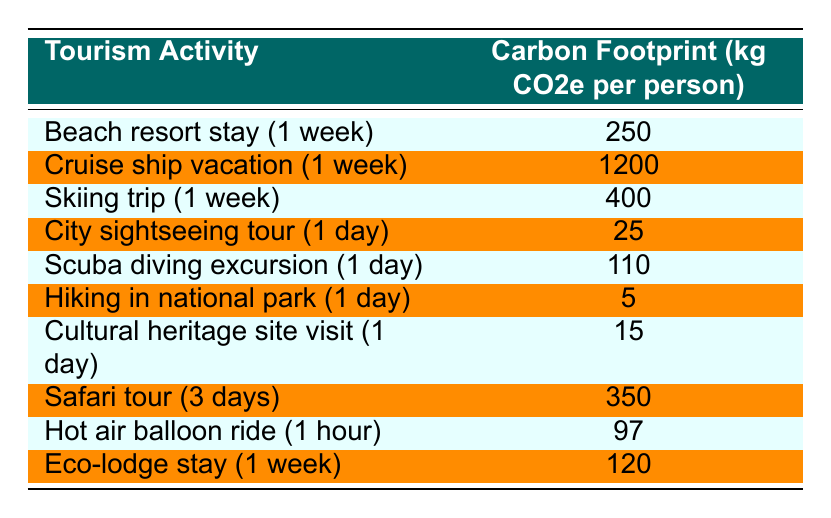What is the carbon footprint of a city sightseeing tour for one day? The table shows that the carbon footprint for a city sightseeing tour (1 day) is listed as 25 kg CO2e per person.
Answer: 25 kg CO2e Which tourism activity has the highest carbon footprint? According to the table, the cruise ship vacation (1 week) has the highest carbon footprint at 1200 kg CO2e per person.
Answer: Cruise ship vacation (1 week) How much more CO2e is produced by a cruise ship vacation compared to a hiking trip in a national park? The carbon footprint for a cruise ship vacation (1 week) is 1200 kg CO2e, while the footprint for hiking in a national park (1 day) is 5 kg CO2e. The difference is 1200 - 5 = 1195 kg CO2e.
Answer: 1195 kg CO2e What is the total carbon footprint of a person doing a skiing trip followed by a scuba diving excursion? From the table, the skiing trip (1 week) has a footprint of 400 kg CO2e and the scuba diving excursion (1 day) has 110 kg CO2e. Adding both gives 400 + 110 = 510 kg CO2e.
Answer: 510 kg CO2e Is the carbon footprint of an eco-lodge stay higher than that of a cultural heritage site visit? The eco-lodge stay (1 week) has a carbon footprint of 120 kg CO2e, while the cultural heritage site visit (1 day) is at 15 kg CO2e. Since 120 is greater than 15, the statement is true.
Answer: Yes How does the carbon footprint of a safari tour compare to that of a hot air balloon ride? The safari tour (3 days) has a carbon footprint of 350 kg CO2e, while the hot air balloon ride (1 hour) has a footprint of 97 kg CO2e. Since 350 is greater than 97, the safari tour has a higher footprint.
Answer: Safari tour has a higher footprint What is the average carbon footprint of a person for the tourism activities listed in the table for activities lasting one day? The activities lasting one day listed are city sightseeing (25 kg), scuba diving (110 kg), hiking (5 kg), and cultural heritage site (15 kg). Summing these gives 25 + 110 + 5 + 15 = 155 kg CO2e. Dividing by the number of activities (4), the average is 155/4 = 38.75 kg CO2e.
Answer: 38.75 kg CO2e Which tourism activities have a carbon footprint of less than 100 kg CO2e? The table shows the carbon footprints of cultural heritage site visit (15 kg), hiking in national park (5 kg), city sightseeing tour (25 kg), and hot air balloon ride (97 kg). These activities have footprints less than 100 kg CO2e.
Answer: Cultural heritage site visit, hiking in national park, city sightseeing tour, hot air balloon ride How much carbon dioxide equivalent would a person produce if they stayed at a beach resort for a week and then went scuba diving for a day? The beach resort stay for a week produces 250 kg CO2e and the scuba diving excursion for a day produces 110 kg CO2e. Adding these two values gives a total of 250 + 110 = 360 kg CO2e.
Answer: 360 kg CO2e 